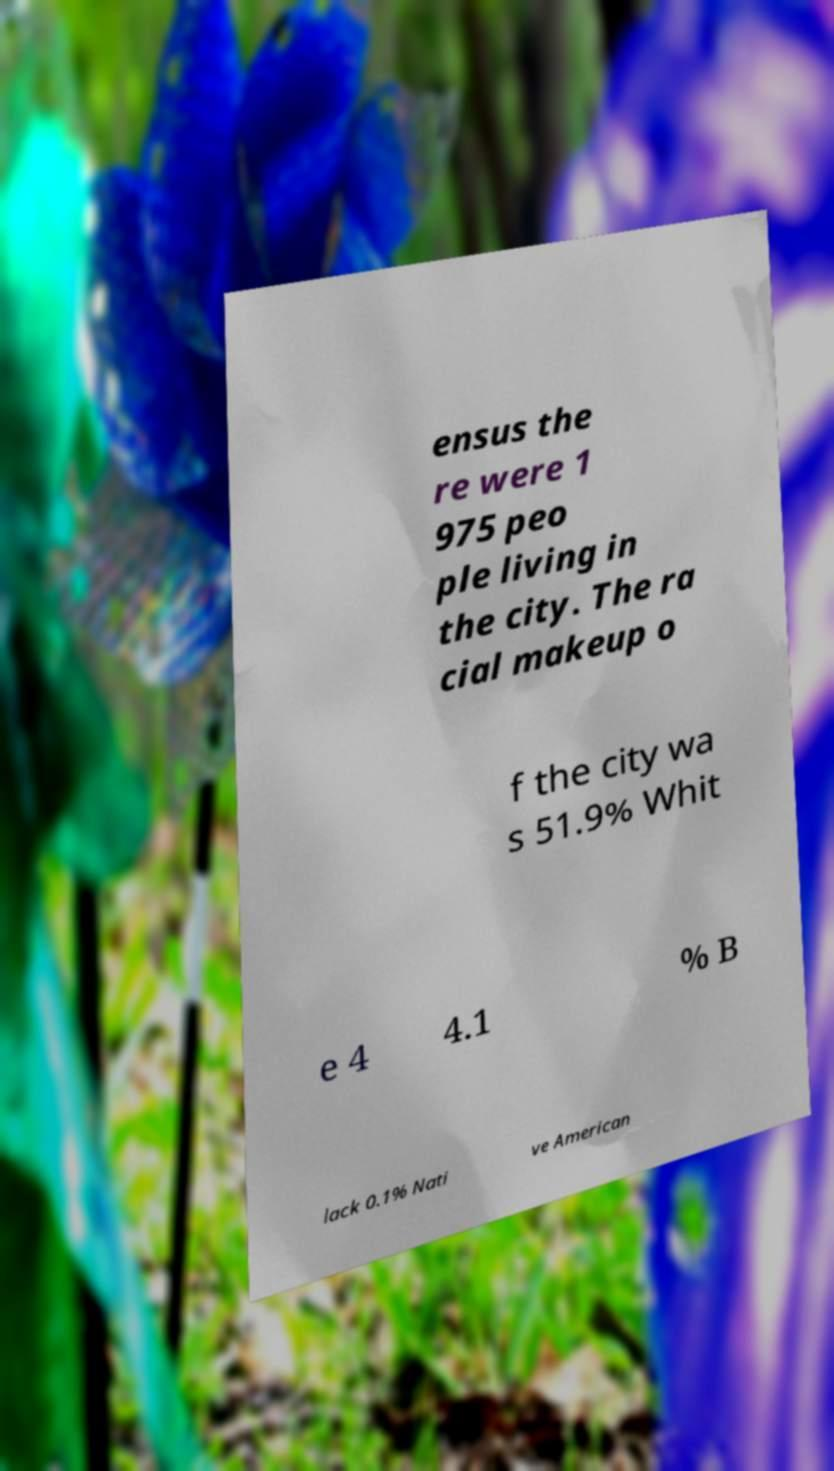Could you assist in decoding the text presented in this image and type it out clearly? ensus the re were 1 975 peo ple living in the city. The ra cial makeup o f the city wa s 51.9% Whit e 4 4.1 % B lack 0.1% Nati ve American 